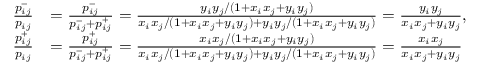Convert formula to latex. <formula><loc_0><loc_0><loc_500><loc_500>\begin{array} { r l } { \frac { p _ { i j } ^ { - } } { p _ { i j } } } & { = \frac { p _ { i j } ^ { - } } { p _ { i j } ^ { - } + p _ { i j } ^ { + } } = \frac { y _ { i } y _ { j } / ( 1 + x _ { i } x _ { j } + y _ { i } y _ { j } ) } { x _ { i } x _ { j } / ( 1 + x _ { i } x _ { j } + y _ { i } y _ { j } ) + y _ { i } y _ { j } / ( 1 + x _ { i } x _ { j } + y _ { i } y _ { j } ) } = \frac { y _ { i } y _ { j } } { x _ { i } x _ { j } + y _ { i } y _ { j } } , } \\ { \frac { p _ { i j } ^ { + } } { p _ { i j } } } & { = \frac { p _ { i j } ^ { + } } { p _ { i j } ^ { - } + p _ { i j } ^ { + } } = \frac { x _ { i } x _ { j } / ( 1 + x _ { i } x _ { j } + y _ { i } y _ { j } ) } { x _ { i } x _ { j } / ( 1 + x _ { i } x _ { j } + y _ { i } y _ { j } ) + y _ { i } y _ { j } / ( 1 + x _ { i } x _ { j } + y _ { i } y _ { j } ) } = \frac { x _ { i } x _ { j } } { x _ { i } x _ { j } + y _ { i } y _ { j } } } \end{array}</formula> 